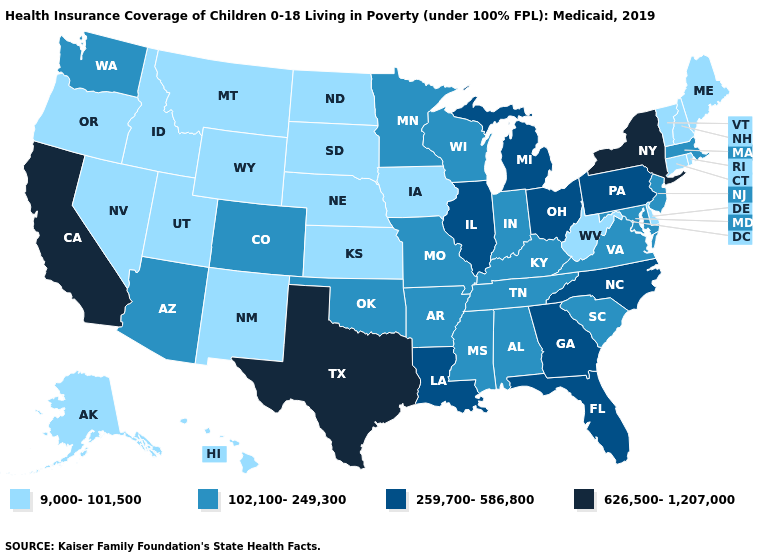Which states have the lowest value in the USA?
Answer briefly. Alaska, Connecticut, Delaware, Hawaii, Idaho, Iowa, Kansas, Maine, Montana, Nebraska, Nevada, New Hampshire, New Mexico, North Dakota, Oregon, Rhode Island, South Dakota, Utah, Vermont, West Virginia, Wyoming. What is the lowest value in states that border Kansas?
Be succinct. 9,000-101,500. Name the states that have a value in the range 259,700-586,800?
Quick response, please. Florida, Georgia, Illinois, Louisiana, Michigan, North Carolina, Ohio, Pennsylvania. Among the states that border Texas , which have the highest value?
Be succinct. Louisiana. What is the value of Indiana?
Keep it brief. 102,100-249,300. Does Idaho have the same value as North Dakota?
Be succinct. Yes. Name the states that have a value in the range 626,500-1,207,000?
Concise answer only. California, New York, Texas. Name the states that have a value in the range 102,100-249,300?
Keep it brief. Alabama, Arizona, Arkansas, Colorado, Indiana, Kentucky, Maryland, Massachusetts, Minnesota, Mississippi, Missouri, New Jersey, Oklahoma, South Carolina, Tennessee, Virginia, Washington, Wisconsin. What is the value of Iowa?
Answer briefly. 9,000-101,500. Which states have the lowest value in the USA?
Short answer required. Alaska, Connecticut, Delaware, Hawaii, Idaho, Iowa, Kansas, Maine, Montana, Nebraska, Nevada, New Hampshire, New Mexico, North Dakota, Oregon, Rhode Island, South Dakota, Utah, Vermont, West Virginia, Wyoming. Which states have the lowest value in the South?
Answer briefly. Delaware, West Virginia. What is the highest value in the USA?
Short answer required. 626,500-1,207,000. Does the map have missing data?
Be succinct. No. What is the lowest value in the West?
Be succinct. 9,000-101,500. What is the lowest value in the West?
Concise answer only. 9,000-101,500. 